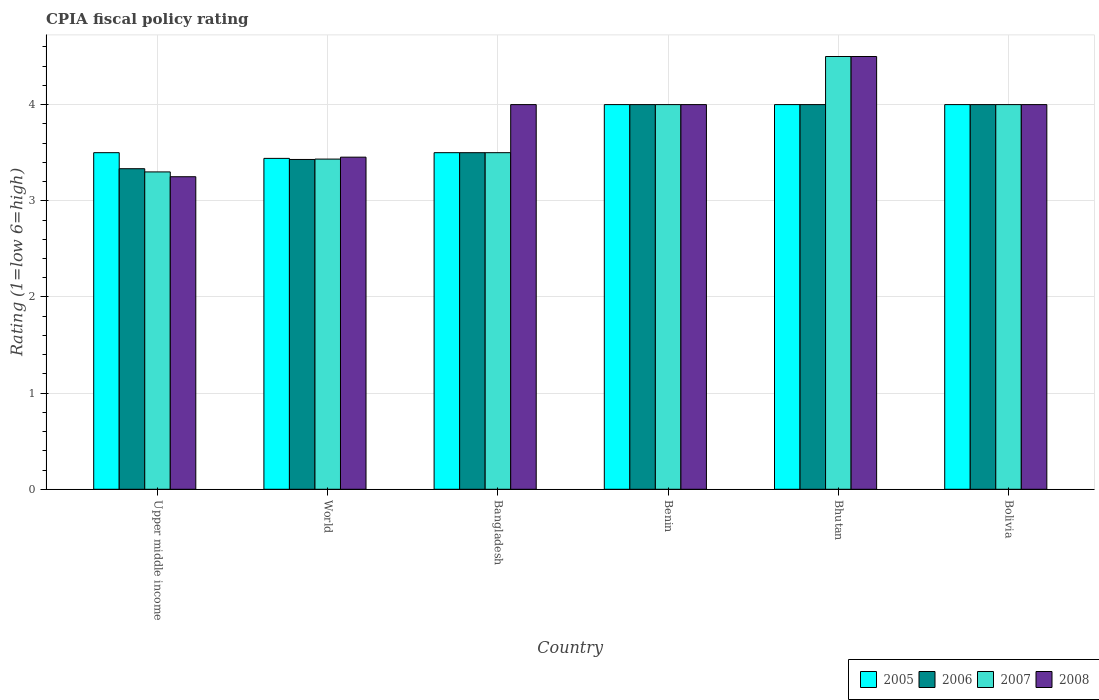How many different coloured bars are there?
Offer a very short reply. 4. How many groups of bars are there?
Make the answer very short. 6. Are the number of bars per tick equal to the number of legend labels?
Provide a succinct answer. Yes. What is the label of the 1st group of bars from the left?
Offer a terse response. Upper middle income. In how many cases, is the number of bars for a given country not equal to the number of legend labels?
Ensure brevity in your answer.  0. What is the CPIA rating in 2006 in Bhutan?
Offer a terse response. 4. In which country was the CPIA rating in 2007 maximum?
Make the answer very short. Bhutan. In which country was the CPIA rating in 2007 minimum?
Keep it short and to the point. Upper middle income. What is the total CPIA rating in 2007 in the graph?
Offer a very short reply. 22.73. What is the difference between the CPIA rating in 2005 in Benin and that in Bolivia?
Provide a succinct answer. 0. What is the difference between the CPIA rating in 2007 in World and the CPIA rating in 2006 in Upper middle income?
Your answer should be very brief. 0.1. What is the average CPIA rating in 2006 per country?
Provide a short and direct response. 3.71. In how many countries, is the CPIA rating in 2007 greater than 2?
Your answer should be compact. 6. What is the ratio of the CPIA rating in 2007 in Benin to that in Bolivia?
Your answer should be very brief. 1. What is the difference between the highest and the second highest CPIA rating in 2007?
Your answer should be very brief. 0.5. What is the difference between the highest and the lowest CPIA rating in 2005?
Offer a terse response. 0.56. Is the sum of the CPIA rating in 2008 in Bhutan and World greater than the maximum CPIA rating in 2007 across all countries?
Give a very brief answer. Yes. Is it the case that in every country, the sum of the CPIA rating in 2005 and CPIA rating in 2006 is greater than the sum of CPIA rating in 2008 and CPIA rating in 2007?
Offer a terse response. No. What does the 2nd bar from the right in World represents?
Offer a very short reply. 2007. How many bars are there?
Keep it short and to the point. 24. Are all the bars in the graph horizontal?
Offer a very short reply. No. What is the difference between two consecutive major ticks on the Y-axis?
Your response must be concise. 1. What is the title of the graph?
Make the answer very short. CPIA fiscal policy rating. What is the label or title of the X-axis?
Give a very brief answer. Country. What is the Rating (1=low 6=high) in 2005 in Upper middle income?
Give a very brief answer. 3.5. What is the Rating (1=low 6=high) of 2006 in Upper middle income?
Give a very brief answer. 3.33. What is the Rating (1=low 6=high) in 2007 in Upper middle income?
Offer a very short reply. 3.3. What is the Rating (1=low 6=high) in 2005 in World?
Your response must be concise. 3.44. What is the Rating (1=low 6=high) of 2006 in World?
Give a very brief answer. 3.43. What is the Rating (1=low 6=high) of 2007 in World?
Keep it short and to the point. 3.43. What is the Rating (1=low 6=high) of 2008 in World?
Offer a terse response. 3.45. What is the Rating (1=low 6=high) in 2008 in Bangladesh?
Provide a succinct answer. 4. What is the Rating (1=low 6=high) of 2005 in Benin?
Give a very brief answer. 4. What is the Rating (1=low 6=high) in 2008 in Benin?
Your response must be concise. 4. What is the Rating (1=low 6=high) of 2005 in Bhutan?
Provide a short and direct response. 4. What is the Rating (1=low 6=high) of 2005 in Bolivia?
Give a very brief answer. 4. What is the Rating (1=low 6=high) of 2007 in Bolivia?
Keep it short and to the point. 4. Across all countries, what is the minimum Rating (1=low 6=high) in 2005?
Provide a short and direct response. 3.44. Across all countries, what is the minimum Rating (1=low 6=high) of 2006?
Make the answer very short. 3.33. What is the total Rating (1=low 6=high) of 2005 in the graph?
Provide a short and direct response. 22.44. What is the total Rating (1=low 6=high) in 2006 in the graph?
Ensure brevity in your answer.  22.26. What is the total Rating (1=low 6=high) in 2007 in the graph?
Ensure brevity in your answer.  22.73. What is the total Rating (1=low 6=high) in 2008 in the graph?
Your answer should be compact. 23.2. What is the difference between the Rating (1=low 6=high) in 2005 in Upper middle income and that in World?
Offer a terse response. 0.06. What is the difference between the Rating (1=low 6=high) of 2006 in Upper middle income and that in World?
Make the answer very short. -0.1. What is the difference between the Rating (1=low 6=high) of 2007 in Upper middle income and that in World?
Provide a succinct answer. -0.13. What is the difference between the Rating (1=low 6=high) in 2008 in Upper middle income and that in World?
Your answer should be compact. -0.2. What is the difference between the Rating (1=low 6=high) in 2005 in Upper middle income and that in Bangladesh?
Give a very brief answer. 0. What is the difference between the Rating (1=low 6=high) of 2008 in Upper middle income and that in Bangladesh?
Provide a short and direct response. -0.75. What is the difference between the Rating (1=low 6=high) of 2005 in Upper middle income and that in Benin?
Ensure brevity in your answer.  -0.5. What is the difference between the Rating (1=low 6=high) in 2007 in Upper middle income and that in Benin?
Make the answer very short. -0.7. What is the difference between the Rating (1=low 6=high) in 2008 in Upper middle income and that in Benin?
Provide a short and direct response. -0.75. What is the difference between the Rating (1=low 6=high) of 2005 in Upper middle income and that in Bhutan?
Provide a succinct answer. -0.5. What is the difference between the Rating (1=low 6=high) of 2007 in Upper middle income and that in Bhutan?
Offer a terse response. -1.2. What is the difference between the Rating (1=low 6=high) of 2008 in Upper middle income and that in Bhutan?
Your response must be concise. -1.25. What is the difference between the Rating (1=low 6=high) in 2005 in Upper middle income and that in Bolivia?
Your response must be concise. -0.5. What is the difference between the Rating (1=low 6=high) of 2007 in Upper middle income and that in Bolivia?
Offer a very short reply. -0.7. What is the difference between the Rating (1=low 6=high) in 2008 in Upper middle income and that in Bolivia?
Offer a very short reply. -0.75. What is the difference between the Rating (1=low 6=high) in 2005 in World and that in Bangladesh?
Provide a short and direct response. -0.06. What is the difference between the Rating (1=low 6=high) in 2006 in World and that in Bangladesh?
Make the answer very short. -0.07. What is the difference between the Rating (1=low 6=high) of 2007 in World and that in Bangladesh?
Keep it short and to the point. -0.07. What is the difference between the Rating (1=low 6=high) in 2008 in World and that in Bangladesh?
Give a very brief answer. -0.55. What is the difference between the Rating (1=low 6=high) in 2005 in World and that in Benin?
Offer a very short reply. -0.56. What is the difference between the Rating (1=low 6=high) in 2006 in World and that in Benin?
Your answer should be compact. -0.57. What is the difference between the Rating (1=low 6=high) in 2007 in World and that in Benin?
Offer a very short reply. -0.57. What is the difference between the Rating (1=low 6=high) in 2008 in World and that in Benin?
Provide a succinct answer. -0.55. What is the difference between the Rating (1=low 6=high) of 2005 in World and that in Bhutan?
Offer a very short reply. -0.56. What is the difference between the Rating (1=low 6=high) of 2006 in World and that in Bhutan?
Keep it short and to the point. -0.57. What is the difference between the Rating (1=low 6=high) in 2007 in World and that in Bhutan?
Provide a succinct answer. -1.07. What is the difference between the Rating (1=low 6=high) of 2008 in World and that in Bhutan?
Give a very brief answer. -1.05. What is the difference between the Rating (1=low 6=high) of 2005 in World and that in Bolivia?
Your response must be concise. -0.56. What is the difference between the Rating (1=low 6=high) of 2006 in World and that in Bolivia?
Your answer should be compact. -0.57. What is the difference between the Rating (1=low 6=high) in 2007 in World and that in Bolivia?
Your answer should be compact. -0.57. What is the difference between the Rating (1=low 6=high) of 2008 in World and that in Bolivia?
Provide a succinct answer. -0.55. What is the difference between the Rating (1=low 6=high) of 2007 in Bangladesh and that in Bhutan?
Provide a succinct answer. -1. What is the difference between the Rating (1=low 6=high) in 2008 in Bangladesh and that in Bhutan?
Make the answer very short. -0.5. What is the difference between the Rating (1=low 6=high) of 2005 in Bangladesh and that in Bolivia?
Your answer should be very brief. -0.5. What is the difference between the Rating (1=low 6=high) of 2008 in Bangladesh and that in Bolivia?
Offer a terse response. 0. What is the difference between the Rating (1=low 6=high) in 2005 in Benin and that in Bhutan?
Your response must be concise. 0. What is the difference between the Rating (1=low 6=high) of 2006 in Benin and that in Bhutan?
Offer a very short reply. 0. What is the difference between the Rating (1=low 6=high) of 2007 in Benin and that in Bhutan?
Give a very brief answer. -0.5. What is the difference between the Rating (1=low 6=high) of 2008 in Benin and that in Bhutan?
Keep it short and to the point. -0.5. What is the difference between the Rating (1=low 6=high) in 2005 in Benin and that in Bolivia?
Make the answer very short. 0. What is the difference between the Rating (1=low 6=high) of 2007 in Benin and that in Bolivia?
Provide a short and direct response. 0. What is the difference between the Rating (1=low 6=high) of 2005 in Bhutan and that in Bolivia?
Offer a terse response. 0. What is the difference between the Rating (1=low 6=high) in 2006 in Bhutan and that in Bolivia?
Make the answer very short. 0. What is the difference between the Rating (1=low 6=high) in 2007 in Bhutan and that in Bolivia?
Keep it short and to the point. 0.5. What is the difference between the Rating (1=low 6=high) of 2008 in Bhutan and that in Bolivia?
Give a very brief answer. 0.5. What is the difference between the Rating (1=low 6=high) in 2005 in Upper middle income and the Rating (1=low 6=high) in 2006 in World?
Your response must be concise. 0.07. What is the difference between the Rating (1=low 6=high) of 2005 in Upper middle income and the Rating (1=low 6=high) of 2007 in World?
Your answer should be compact. 0.07. What is the difference between the Rating (1=low 6=high) in 2005 in Upper middle income and the Rating (1=low 6=high) in 2008 in World?
Offer a very short reply. 0.05. What is the difference between the Rating (1=low 6=high) of 2006 in Upper middle income and the Rating (1=low 6=high) of 2008 in World?
Your answer should be compact. -0.12. What is the difference between the Rating (1=low 6=high) of 2007 in Upper middle income and the Rating (1=low 6=high) of 2008 in World?
Your answer should be compact. -0.15. What is the difference between the Rating (1=low 6=high) in 2005 in Upper middle income and the Rating (1=low 6=high) in 2006 in Bangladesh?
Your answer should be compact. 0. What is the difference between the Rating (1=low 6=high) in 2005 in Upper middle income and the Rating (1=low 6=high) in 2007 in Bangladesh?
Make the answer very short. 0. What is the difference between the Rating (1=low 6=high) in 2005 in Upper middle income and the Rating (1=low 6=high) in 2006 in Benin?
Offer a very short reply. -0.5. What is the difference between the Rating (1=low 6=high) in 2005 in Upper middle income and the Rating (1=low 6=high) in 2008 in Benin?
Your answer should be compact. -0.5. What is the difference between the Rating (1=low 6=high) in 2006 in Upper middle income and the Rating (1=low 6=high) in 2007 in Benin?
Provide a short and direct response. -0.67. What is the difference between the Rating (1=low 6=high) in 2007 in Upper middle income and the Rating (1=low 6=high) in 2008 in Benin?
Provide a succinct answer. -0.7. What is the difference between the Rating (1=low 6=high) in 2005 in Upper middle income and the Rating (1=low 6=high) in 2006 in Bhutan?
Your answer should be very brief. -0.5. What is the difference between the Rating (1=low 6=high) of 2006 in Upper middle income and the Rating (1=low 6=high) of 2007 in Bhutan?
Give a very brief answer. -1.17. What is the difference between the Rating (1=low 6=high) in 2006 in Upper middle income and the Rating (1=low 6=high) in 2008 in Bhutan?
Provide a short and direct response. -1.17. What is the difference between the Rating (1=low 6=high) in 2007 in Upper middle income and the Rating (1=low 6=high) in 2008 in Bhutan?
Provide a short and direct response. -1.2. What is the difference between the Rating (1=low 6=high) in 2005 in Upper middle income and the Rating (1=low 6=high) in 2008 in Bolivia?
Your answer should be compact. -0.5. What is the difference between the Rating (1=low 6=high) of 2006 in Upper middle income and the Rating (1=low 6=high) of 2007 in Bolivia?
Keep it short and to the point. -0.67. What is the difference between the Rating (1=low 6=high) in 2006 in Upper middle income and the Rating (1=low 6=high) in 2008 in Bolivia?
Your answer should be compact. -0.67. What is the difference between the Rating (1=low 6=high) in 2007 in Upper middle income and the Rating (1=low 6=high) in 2008 in Bolivia?
Ensure brevity in your answer.  -0.7. What is the difference between the Rating (1=low 6=high) of 2005 in World and the Rating (1=low 6=high) of 2006 in Bangladesh?
Give a very brief answer. -0.06. What is the difference between the Rating (1=low 6=high) of 2005 in World and the Rating (1=low 6=high) of 2007 in Bangladesh?
Give a very brief answer. -0.06. What is the difference between the Rating (1=low 6=high) in 2005 in World and the Rating (1=low 6=high) in 2008 in Bangladesh?
Your answer should be very brief. -0.56. What is the difference between the Rating (1=low 6=high) in 2006 in World and the Rating (1=low 6=high) in 2007 in Bangladesh?
Provide a succinct answer. -0.07. What is the difference between the Rating (1=low 6=high) in 2006 in World and the Rating (1=low 6=high) in 2008 in Bangladesh?
Offer a very short reply. -0.57. What is the difference between the Rating (1=low 6=high) in 2007 in World and the Rating (1=low 6=high) in 2008 in Bangladesh?
Give a very brief answer. -0.57. What is the difference between the Rating (1=low 6=high) of 2005 in World and the Rating (1=low 6=high) of 2006 in Benin?
Offer a very short reply. -0.56. What is the difference between the Rating (1=low 6=high) in 2005 in World and the Rating (1=low 6=high) in 2007 in Benin?
Provide a short and direct response. -0.56. What is the difference between the Rating (1=low 6=high) in 2005 in World and the Rating (1=low 6=high) in 2008 in Benin?
Make the answer very short. -0.56. What is the difference between the Rating (1=low 6=high) in 2006 in World and the Rating (1=low 6=high) in 2007 in Benin?
Keep it short and to the point. -0.57. What is the difference between the Rating (1=low 6=high) of 2006 in World and the Rating (1=low 6=high) of 2008 in Benin?
Offer a terse response. -0.57. What is the difference between the Rating (1=low 6=high) of 2007 in World and the Rating (1=low 6=high) of 2008 in Benin?
Make the answer very short. -0.57. What is the difference between the Rating (1=low 6=high) of 2005 in World and the Rating (1=low 6=high) of 2006 in Bhutan?
Your answer should be compact. -0.56. What is the difference between the Rating (1=low 6=high) in 2005 in World and the Rating (1=low 6=high) in 2007 in Bhutan?
Provide a short and direct response. -1.06. What is the difference between the Rating (1=low 6=high) of 2005 in World and the Rating (1=low 6=high) of 2008 in Bhutan?
Ensure brevity in your answer.  -1.06. What is the difference between the Rating (1=low 6=high) of 2006 in World and the Rating (1=low 6=high) of 2007 in Bhutan?
Make the answer very short. -1.07. What is the difference between the Rating (1=low 6=high) of 2006 in World and the Rating (1=low 6=high) of 2008 in Bhutan?
Ensure brevity in your answer.  -1.07. What is the difference between the Rating (1=low 6=high) of 2007 in World and the Rating (1=low 6=high) of 2008 in Bhutan?
Make the answer very short. -1.07. What is the difference between the Rating (1=low 6=high) in 2005 in World and the Rating (1=low 6=high) in 2006 in Bolivia?
Provide a short and direct response. -0.56. What is the difference between the Rating (1=low 6=high) of 2005 in World and the Rating (1=low 6=high) of 2007 in Bolivia?
Give a very brief answer. -0.56. What is the difference between the Rating (1=low 6=high) of 2005 in World and the Rating (1=low 6=high) of 2008 in Bolivia?
Give a very brief answer. -0.56. What is the difference between the Rating (1=low 6=high) of 2006 in World and the Rating (1=low 6=high) of 2007 in Bolivia?
Your answer should be compact. -0.57. What is the difference between the Rating (1=low 6=high) of 2006 in World and the Rating (1=low 6=high) of 2008 in Bolivia?
Provide a succinct answer. -0.57. What is the difference between the Rating (1=low 6=high) in 2007 in World and the Rating (1=low 6=high) in 2008 in Bolivia?
Offer a terse response. -0.57. What is the difference between the Rating (1=low 6=high) of 2005 in Bangladesh and the Rating (1=low 6=high) of 2006 in Bhutan?
Offer a terse response. -0.5. What is the difference between the Rating (1=low 6=high) of 2005 in Bangladesh and the Rating (1=low 6=high) of 2008 in Bhutan?
Give a very brief answer. -1. What is the difference between the Rating (1=low 6=high) of 2006 in Bangladesh and the Rating (1=low 6=high) of 2007 in Bhutan?
Provide a short and direct response. -1. What is the difference between the Rating (1=low 6=high) in 2007 in Bangladesh and the Rating (1=low 6=high) in 2008 in Bhutan?
Offer a terse response. -1. What is the difference between the Rating (1=low 6=high) of 2005 in Bangladesh and the Rating (1=low 6=high) of 2008 in Bolivia?
Your response must be concise. -0.5. What is the difference between the Rating (1=low 6=high) in 2006 in Bangladesh and the Rating (1=low 6=high) in 2008 in Bolivia?
Provide a short and direct response. -0.5. What is the difference between the Rating (1=low 6=high) in 2007 in Bangladesh and the Rating (1=low 6=high) in 2008 in Bolivia?
Ensure brevity in your answer.  -0.5. What is the difference between the Rating (1=low 6=high) in 2005 in Benin and the Rating (1=low 6=high) in 2006 in Bhutan?
Make the answer very short. 0. What is the difference between the Rating (1=low 6=high) in 2005 in Benin and the Rating (1=low 6=high) in 2008 in Bhutan?
Provide a succinct answer. -0.5. What is the difference between the Rating (1=low 6=high) in 2006 in Benin and the Rating (1=low 6=high) in 2007 in Bhutan?
Keep it short and to the point. -0.5. What is the difference between the Rating (1=low 6=high) of 2007 in Benin and the Rating (1=low 6=high) of 2008 in Bhutan?
Offer a very short reply. -0.5. What is the difference between the Rating (1=low 6=high) of 2005 in Benin and the Rating (1=low 6=high) of 2006 in Bolivia?
Provide a short and direct response. 0. What is the difference between the Rating (1=low 6=high) in 2005 in Benin and the Rating (1=low 6=high) in 2007 in Bolivia?
Offer a terse response. 0. What is the difference between the Rating (1=low 6=high) of 2005 in Benin and the Rating (1=low 6=high) of 2008 in Bolivia?
Keep it short and to the point. 0. What is the difference between the Rating (1=low 6=high) of 2006 in Benin and the Rating (1=low 6=high) of 2007 in Bolivia?
Offer a terse response. 0. What is the difference between the Rating (1=low 6=high) of 2007 in Benin and the Rating (1=low 6=high) of 2008 in Bolivia?
Give a very brief answer. 0. What is the difference between the Rating (1=low 6=high) in 2005 in Bhutan and the Rating (1=low 6=high) in 2006 in Bolivia?
Offer a terse response. 0. What is the difference between the Rating (1=low 6=high) of 2007 in Bhutan and the Rating (1=low 6=high) of 2008 in Bolivia?
Offer a terse response. 0.5. What is the average Rating (1=low 6=high) of 2005 per country?
Ensure brevity in your answer.  3.74. What is the average Rating (1=low 6=high) of 2006 per country?
Offer a terse response. 3.71. What is the average Rating (1=low 6=high) of 2007 per country?
Your answer should be very brief. 3.79. What is the average Rating (1=low 6=high) in 2008 per country?
Your answer should be very brief. 3.87. What is the difference between the Rating (1=low 6=high) of 2006 and Rating (1=low 6=high) of 2008 in Upper middle income?
Offer a very short reply. 0.08. What is the difference between the Rating (1=low 6=high) in 2007 and Rating (1=low 6=high) in 2008 in Upper middle income?
Offer a terse response. 0.05. What is the difference between the Rating (1=low 6=high) in 2005 and Rating (1=low 6=high) in 2006 in World?
Give a very brief answer. 0.01. What is the difference between the Rating (1=low 6=high) in 2005 and Rating (1=low 6=high) in 2007 in World?
Provide a succinct answer. 0.01. What is the difference between the Rating (1=low 6=high) of 2005 and Rating (1=low 6=high) of 2008 in World?
Your answer should be very brief. -0.01. What is the difference between the Rating (1=low 6=high) in 2006 and Rating (1=low 6=high) in 2007 in World?
Make the answer very short. -0. What is the difference between the Rating (1=low 6=high) in 2006 and Rating (1=low 6=high) in 2008 in World?
Offer a terse response. -0.02. What is the difference between the Rating (1=low 6=high) of 2007 and Rating (1=low 6=high) of 2008 in World?
Give a very brief answer. -0.02. What is the difference between the Rating (1=low 6=high) in 2005 and Rating (1=low 6=high) in 2006 in Bangladesh?
Ensure brevity in your answer.  0. What is the difference between the Rating (1=low 6=high) of 2005 and Rating (1=low 6=high) of 2007 in Bangladesh?
Offer a terse response. 0. What is the difference between the Rating (1=low 6=high) in 2005 and Rating (1=low 6=high) in 2008 in Bangladesh?
Your response must be concise. -0.5. What is the difference between the Rating (1=low 6=high) of 2006 and Rating (1=low 6=high) of 2008 in Bangladesh?
Offer a very short reply. -0.5. What is the difference between the Rating (1=low 6=high) of 2007 and Rating (1=low 6=high) of 2008 in Bangladesh?
Your answer should be very brief. -0.5. What is the difference between the Rating (1=low 6=high) of 2007 and Rating (1=low 6=high) of 2008 in Benin?
Your response must be concise. 0. What is the difference between the Rating (1=low 6=high) of 2005 and Rating (1=low 6=high) of 2006 in Bhutan?
Your response must be concise. 0. What is the difference between the Rating (1=low 6=high) in 2005 and Rating (1=low 6=high) in 2007 in Bhutan?
Your response must be concise. -0.5. What is the difference between the Rating (1=low 6=high) in 2005 and Rating (1=low 6=high) in 2007 in Bolivia?
Provide a succinct answer. 0. What is the difference between the Rating (1=low 6=high) in 2006 and Rating (1=low 6=high) in 2007 in Bolivia?
Give a very brief answer. 0. What is the difference between the Rating (1=low 6=high) of 2006 and Rating (1=low 6=high) of 2008 in Bolivia?
Make the answer very short. 0. What is the difference between the Rating (1=low 6=high) in 2007 and Rating (1=low 6=high) in 2008 in Bolivia?
Offer a very short reply. 0. What is the ratio of the Rating (1=low 6=high) in 2005 in Upper middle income to that in World?
Keep it short and to the point. 1.02. What is the ratio of the Rating (1=low 6=high) in 2006 in Upper middle income to that in World?
Offer a terse response. 0.97. What is the ratio of the Rating (1=low 6=high) in 2007 in Upper middle income to that in World?
Your response must be concise. 0.96. What is the ratio of the Rating (1=low 6=high) in 2008 in Upper middle income to that in World?
Ensure brevity in your answer.  0.94. What is the ratio of the Rating (1=low 6=high) of 2007 in Upper middle income to that in Bangladesh?
Your answer should be compact. 0.94. What is the ratio of the Rating (1=low 6=high) in 2008 in Upper middle income to that in Bangladesh?
Offer a terse response. 0.81. What is the ratio of the Rating (1=low 6=high) of 2007 in Upper middle income to that in Benin?
Offer a terse response. 0.82. What is the ratio of the Rating (1=low 6=high) of 2008 in Upper middle income to that in Benin?
Your answer should be compact. 0.81. What is the ratio of the Rating (1=low 6=high) of 2006 in Upper middle income to that in Bhutan?
Ensure brevity in your answer.  0.83. What is the ratio of the Rating (1=low 6=high) in 2007 in Upper middle income to that in Bhutan?
Offer a terse response. 0.73. What is the ratio of the Rating (1=low 6=high) in 2008 in Upper middle income to that in Bhutan?
Provide a succinct answer. 0.72. What is the ratio of the Rating (1=low 6=high) in 2006 in Upper middle income to that in Bolivia?
Your response must be concise. 0.83. What is the ratio of the Rating (1=low 6=high) in 2007 in Upper middle income to that in Bolivia?
Give a very brief answer. 0.82. What is the ratio of the Rating (1=low 6=high) of 2008 in Upper middle income to that in Bolivia?
Make the answer very short. 0.81. What is the ratio of the Rating (1=low 6=high) of 2005 in World to that in Bangladesh?
Ensure brevity in your answer.  0.98. What is the ratio of the Rating (1=low 6=high) in 2006 in World to that in Bangladesh?
Give a very brief answer. 0.98. What is the ratio of the Rating (1=low 6=high) in 2008 in World to that in Bangladesh?
Offer a terse response. 0.86. What is the ratio of the Rating (1=low 6=high) in 2005 in World to that in Benin?
Keep it short and to the point. 0.86. What is the ratio of the Rating (1=low 6=high) in 2006 in World to that in Benin?
Give a very brief answer. 0.86. What is the ratio of the Rating (1=low 6=high) of 2007 in World to that in Benin?
Make the answer very short. 0.86. What is the ratio of the Rating (1=low 6=high) of 2008 in World to that in Benin?
Make the answer very short. 0.86. What is the ratio of the Rating (1=low 6=high) of 2005 in World to that in Bhutan?
Make the answer very short. 0.86. What is the ratio of the Rating (1=low 6=high) of 2006 in World to that in Bhutan?
Your answer should be very brief. 0.86. What is the ratio of the Rating (1=low 6=high) of 2007 in World to that in Bhutan?
Keep it short and to the point. 0.76. What is the ratio of the Rating (1=low 6=high) in 2008 in World to that in Bhutan?
Your answer should be compact. 0.77. What is the ratio of the Rating (1=low 6=high) in 2005 in World to that in Bolivia?
Your response must be concise. 0.86. What is the ratio of the Rating (1=low 6=high) in 2006 in World to that in Bolivia?
Give a very brief answer. 0.86. What is the ratio of the Rating (1=low 6=high) in 2007 in World to that in Bolivia?
Your response must be concise. 0.86. What is the ratio of the Rating (1=low 6=high) of 2008 in World to that in Bolivia?
Offer a very short reply. 0.86. What is the ratio of the Rating (1=low 6=high) of 2005 in Bangladesh to that in Benin?
Provide a short and direct response. 0.88. What is the ratio of the Rating (1=low 6=high) of 2008 in Bangladesh to that in Benin?
Your answer should be compact. 1. What is the ratio of the Rating (1=low 6=high) in 2005 in Bangladesh to that in Bhutan?
Your answer should be very brief. 0.88. What is the ratio of the Rating (1=low 6=high) in 2006 in Bangladesh to that in Bhutan?
Your answer should be very brief. 0.88. What is the ratio of the Rating (1=low 6=high) of 2006 in Bangladesh to that in Bolivia?
Your response must be concise. 0.88. What is the ratio of the Rating (1=low 6=high) in 2005 in Benin to that in Bhutan?
Your answer should be compact. 1. What is the ratio of the Rating (1=low 6=high) in 2006 in Benin to that in Bhutan?
Your answer should be very brief. 1. What is the ratio of the Rating (1=low 6=high) in 2007 in Benin to that in Bhutan?
Make the answer very short. 0.89. What is the ratio of the Rating (1=low 6=high) of 2008 in Benin to that in Bhutan?
Provide a short and direct response. 0.89. What is the ratio of the Rating (1=low 6=high) in 2005 in Benin to that in Bolivia?
Give a very brief answer. 1. What is the ratio of the Rating (1=low 6=high) of 2006 in Benin to that in Bolivia?
Your response must be concise. 1. What is the ratio of the Rating (1=low 6=high) of 2007 in Benin to that in Bolivia?
Your response must be concise. 1. What is the ratio of the Rating (1=low 6=high) of 2005 in Bhutan to that in Bolivia?
Provide a short and direct response. 1. What is the ratio of the Rating (1=low 6=high) of 2006 in Bhutan to that in Bolivia?
Keep it short and to the point. 1. What is the ratio of the Rating (1=low 6=high) in 2008 in Bhutan to that in Bolivia?
Offer a terse response. 1.12. What is the difference between the highest and the second highest Rating (1=low 6=high) of 2005?
Make the answer very short. 0. What is the difference between the highest and the second highest Rating (1=low 6=high) in 2008?
Ensure brevity in your answer.  0.5. What is the difference between the highest and the lowest Rating (1=low 6=high) in 2005?
Provide a succinct answer. 0.56. What is the difference between the highest and the lowest Rating (1=low 6=high) of 2006?
Ensure brevity in your answer.  0.67. What is the difference between the highest and the lowest Rating (1=low 6=high) of 2008?
Provide a short and direct response. 1.25. 